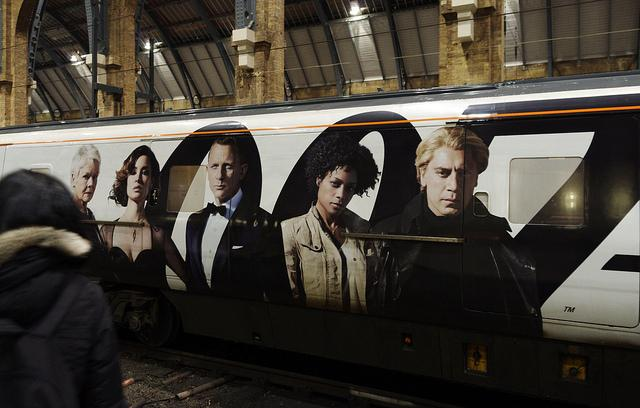Which franchise is advertised here?

Choices:
A) james bond
B) sherlock holmes
C) x men
D) star wars james bond 